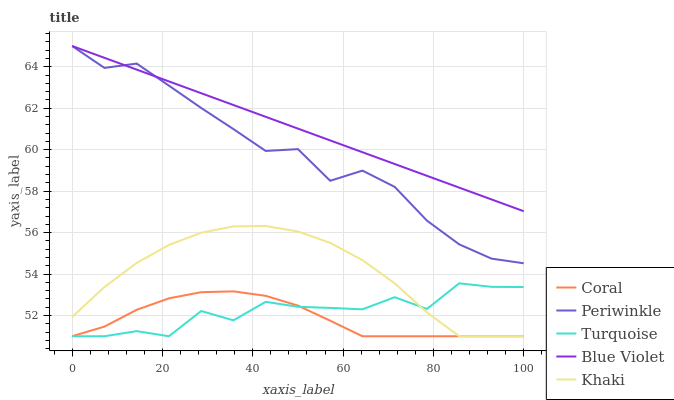Does Coral have the minimum area under the curve?
Answer yes or no. Yes. Does Blue Violet have the maximum area under the curve?
Answer yes or no. Yes. Does Khaki have the minimum area under the curve?
Answer yes or no. No. Does Khaki have the maximum area under the curve?
Answer yes or no. No. Is Blue Violet the smoothest?
Answer yes or no. Yes. Is Turquoise the roughest?
Answer yes or no. Yes. Is Khaki the smoothest?
Answer yes or no. No. Is Khaki the roughest?
Answer yes or no. No. Does Periwinkle have the lowest value?
Answer yes or no. No. Does Blue Violet have the highest value?
Answer yes or no. Yes. Does Khaki have the highest value?
Answer yes or no. No. Is Khaki less than Blue Violet?
Answer yes or no. Yes. Is Blue Violet greater than Turquoise?
Answer yes or no. Yes. Does Turquoise intersect Khaki?
Answer yes or no. Yes. Is Turquoise less than Khaki?
Answer yes or no. No. Is Turquoise greater than Khaki?
Answer yes or no. No. Does Khaki intersect Blue Violet?
Answer yes or no. No. 